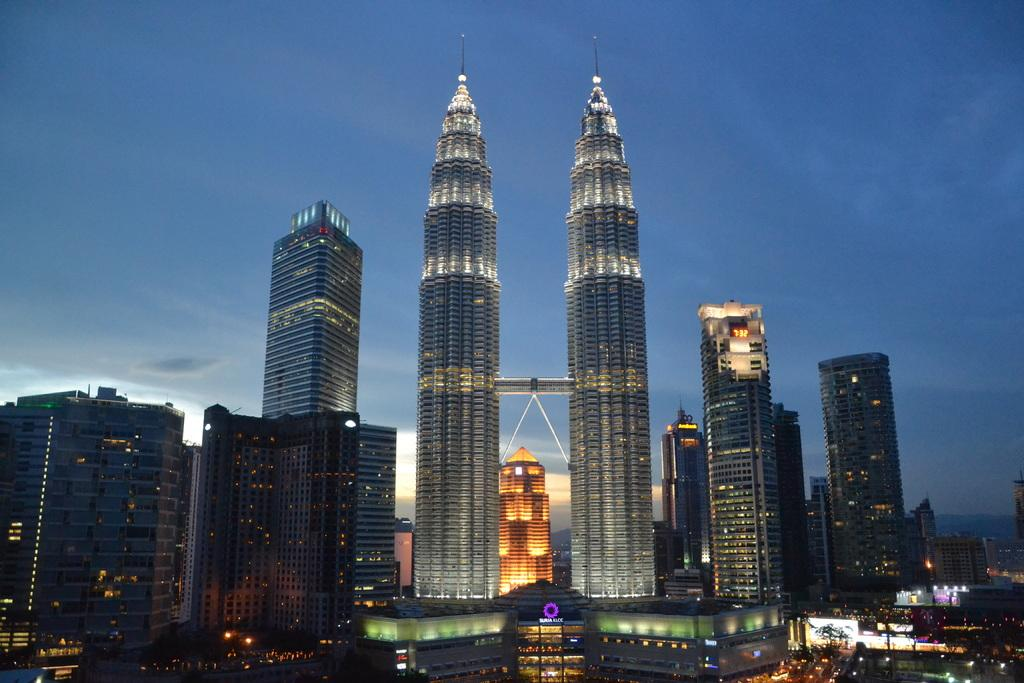What type of structures can be seen in the image? There are many buildings in the image. Are there any visible light sources in the image? Yes, there are lights visible in the image. What other objects can be seen in the image besides buildings and lights? There are various objects in the image. What can be seen in the sky in the background of the image? There are clouds in the sky in the background of the image. How does the son contribute to the balance of the image? There is no son present in the image, so the concept of balance cannot be applied to a person in this context. 